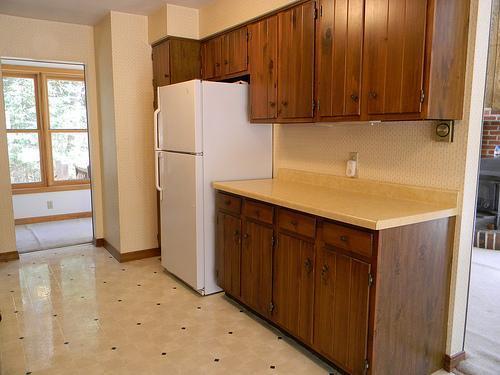How many doors are above the refrigerator?
Give a very brief answer. 2. How many electrical outlets are there?
Give a very brief answer. 2. 